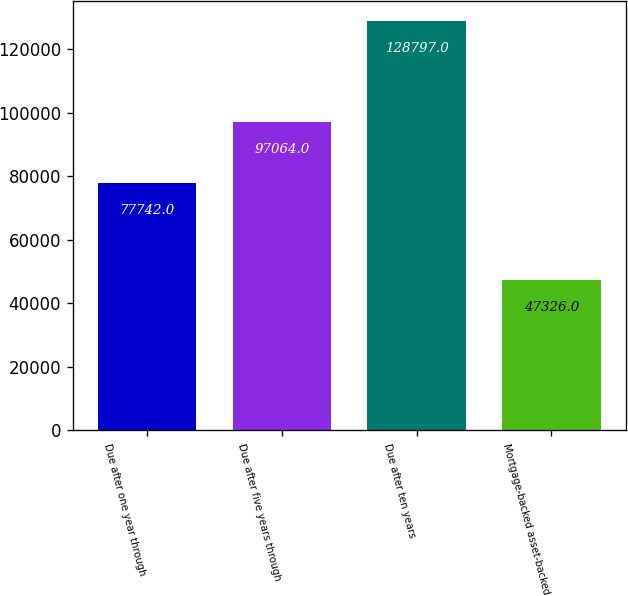<chart> <loc_0><loc_0><loc_500><loc_500><bar_chart><fcel>Due after one year through<fcel>Due after five years through<fcel>Due after ten years<fcel>Mortgage-backed asset-backed<nl><fcel>77742<fcel>97064<fcel>128797<fcel>47326<nl></chart> 